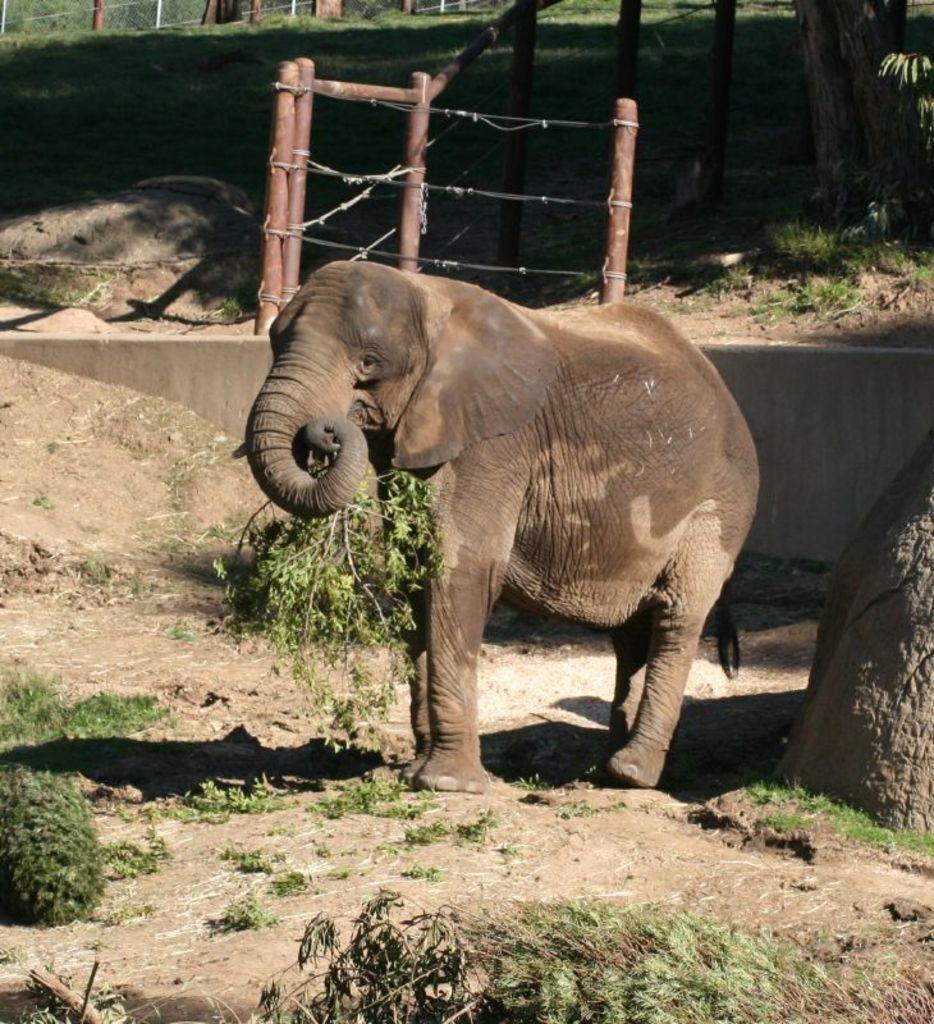Could you give a brief overview of what you see in this image? In this picture we can see an elephant on the ground and in the background we can see a fence,grass. 